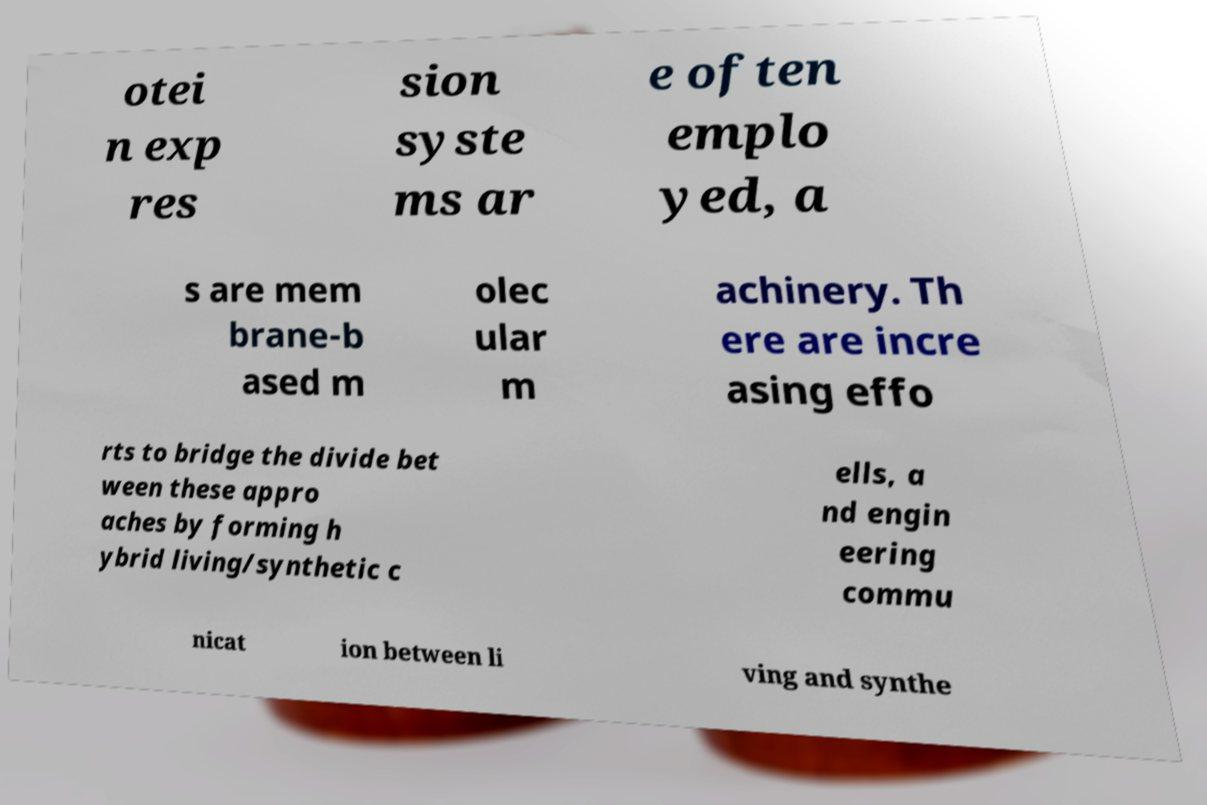Could you extract and type out the text from this image? otei n exp res sion syste ms ar e often emplo yed, a s are mem brane-b ased m olec ular m achinery. Th ere are incre asing effo rts to bridge the divide bet ween these appro aches by forming h ybrid living/synthetic c ells, a nd engin eering commu nicat ion between li ving and synthe 